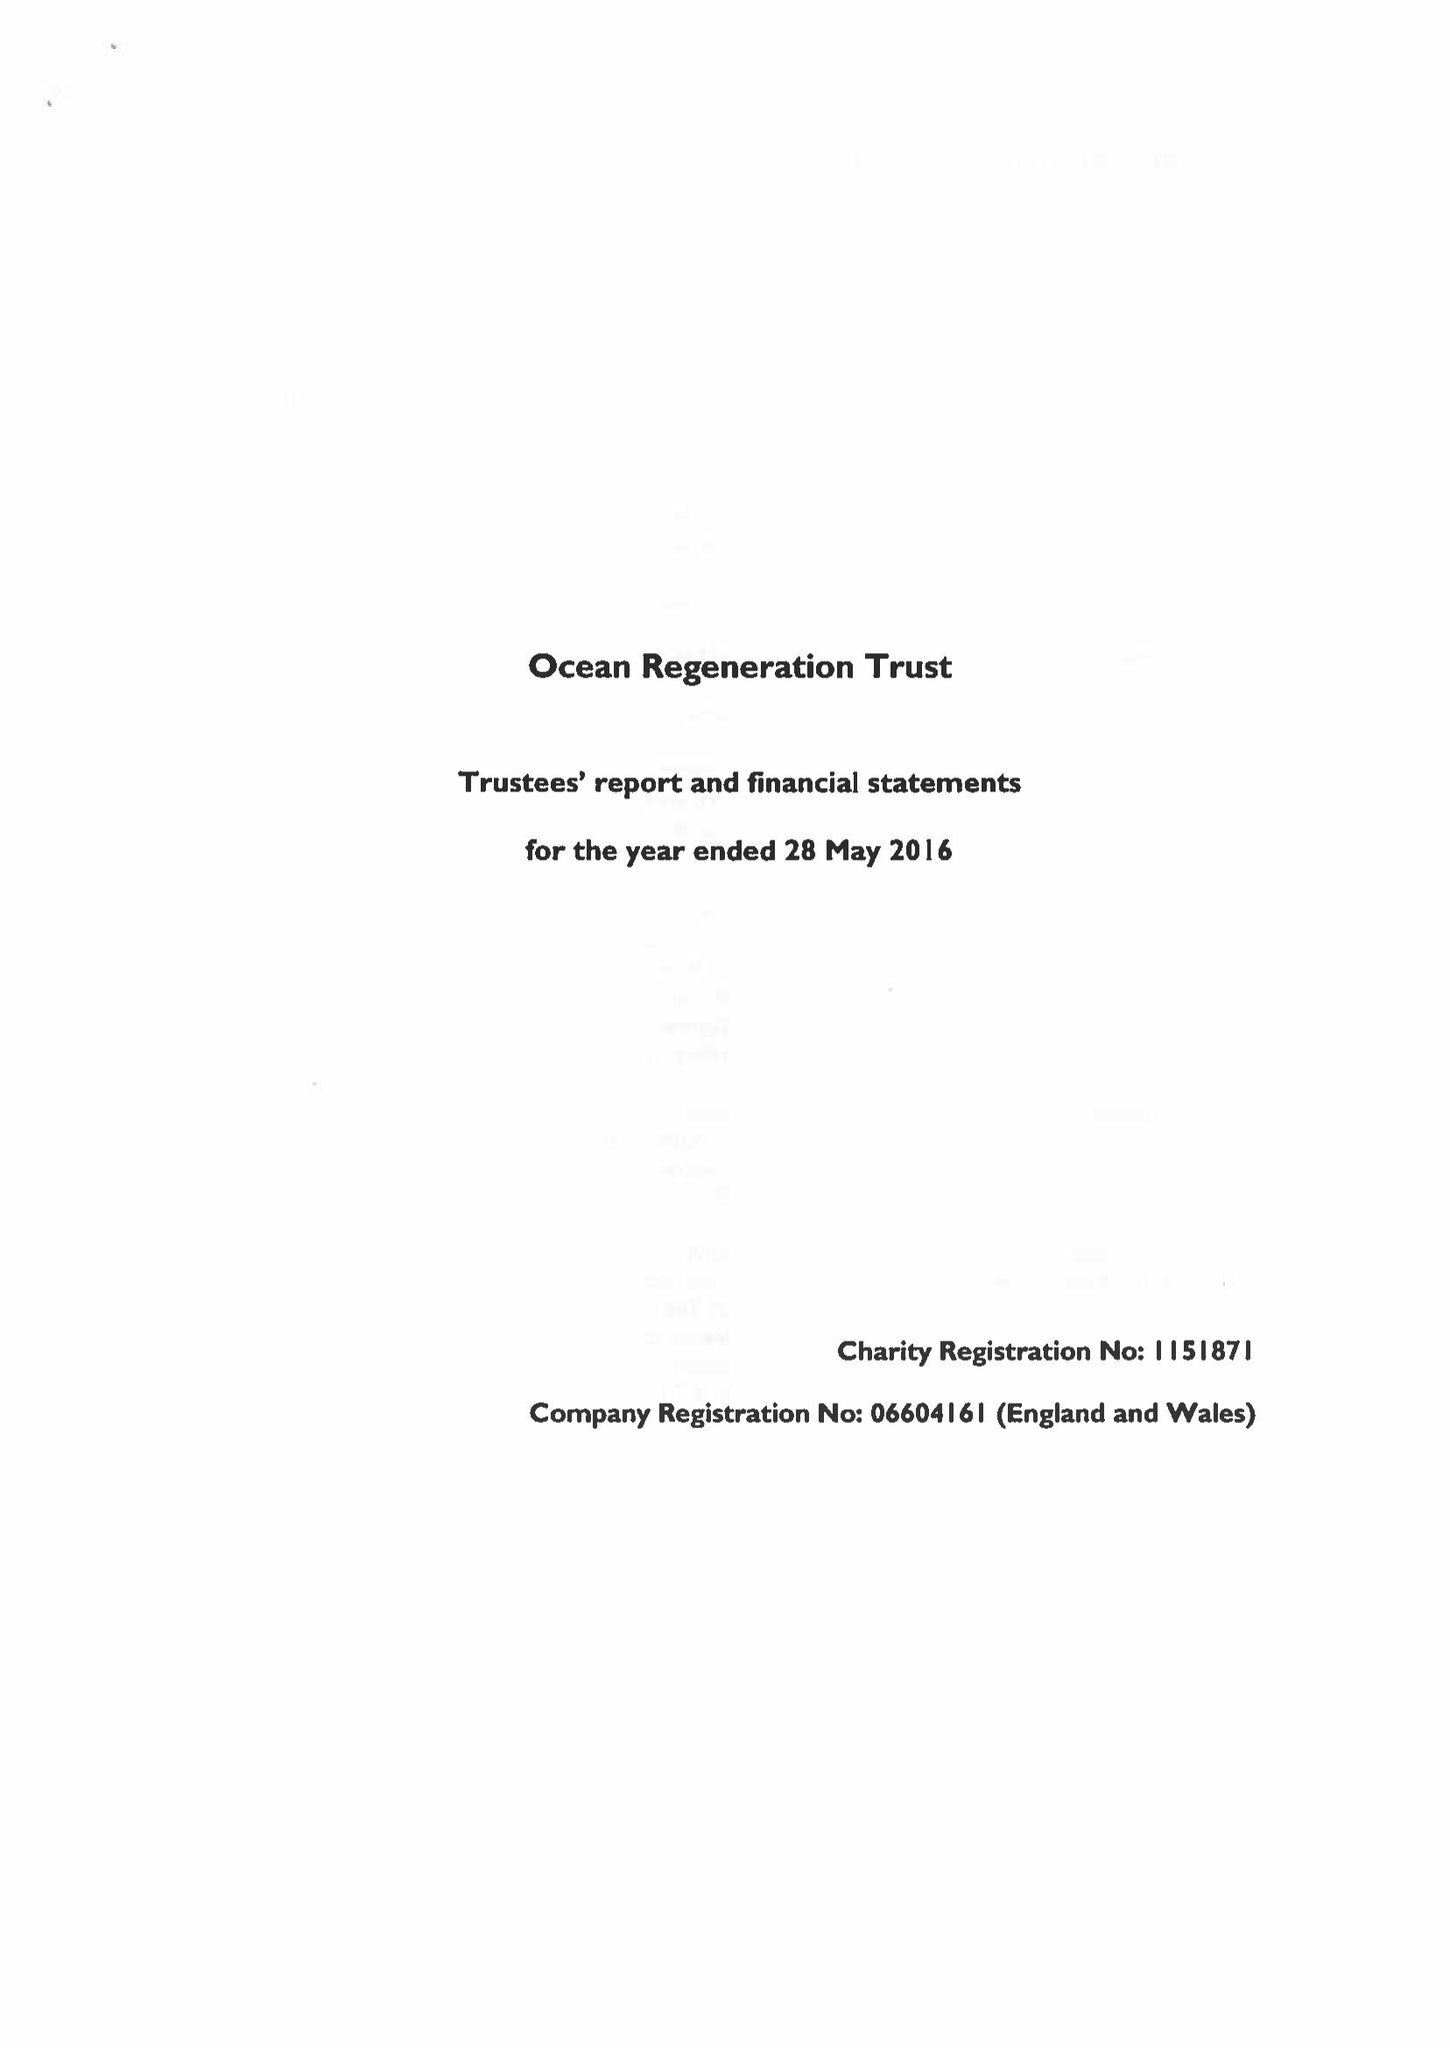What is the value for the income_annually_in_british_pounds?
Answer the question using a single word or phrase. 235451.00 